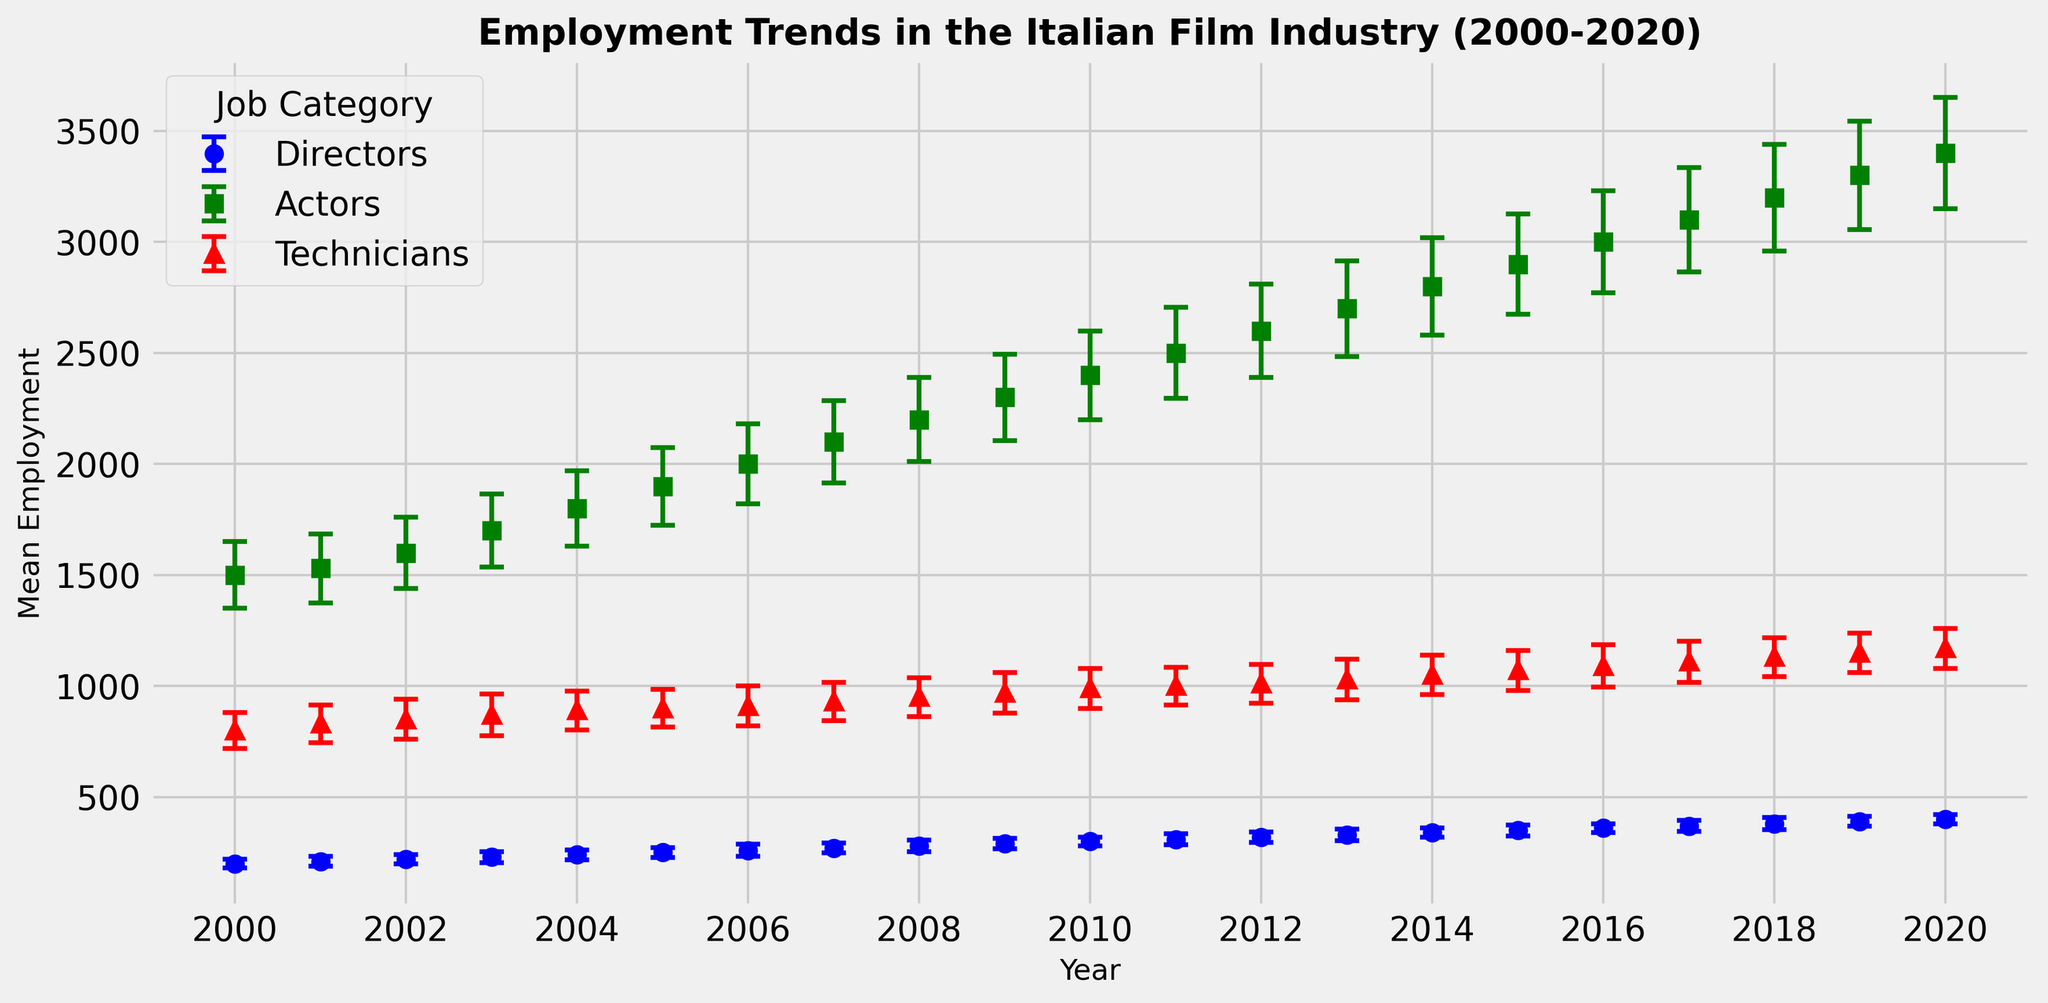What year had the highest mean employment for actors, and what was the mean employment? Look at the green markers representing actors and identify which year has the highest position on the y-axis. According to the plot, that year is 2020 with a mean employment of 3400.
Answer: 2020, 3400 Between which years did the mean employment for technicians increase the most? Examine the red markers for technicians and compare the vertical distances between points year by year. The largest increase appears between 2013 and 2014, where the mean employment increased from 1030 to 1050.
Answer: 2013 to 2014 What is the average mean employment of directors over the period 2000-2020? Sum up the mean employment values for directors from 2000 to 2020 and divide by the number of years (21). Sum: (200 + 210 + 220 + 230 + 240 + 250 + 260 + 270 + 280 + 290 + 300 + 310 + 320 + 330 + 340 + 350 + 360 + 370 + 380 + 390 + 400) = 6300. Thus, 6300 / 21 ≈ 300.
Answer: 300 Which job category shows the most variation in mean employment based on the error bars? Compare the lengths of the error bars for the three job categories. Actors, represented by green markers, have the longest error bars, indicating the greatest variation.
Answer: Actors How did the mean employment trend for directors change from 2000 to 2020? Follow the blue markers corresponding to directors from 2000 to 2020. The markers show a continuous upward trend, indicating a steady increase in mean employment.
Answer: Increased In which year did the mean employment for actors exceed 3000 for the first time? Locate the green markers for actors and find the point where the y-axis value exceeds 3000. This happens in 2015.
Answer: 2015 What is the difference in mean employment between actors and technicians in 2020? Observe the mean employment values for 2020: Actors have 3400 and Technicians have 1170. The difference is 3400 - 1170 = 2230.
Answer: 2230 How does the growth rate of mean employment for technicians from 2000 to 2020 compare with that of directors over the same period? Calculate the initial and final employment for both categories (directors: 200 to 400, technicians: 800 to 1170). For directors, growth is ((400 - 200) / 200) * 100% = 100%. For technicians, growth is ((1170 - 800) / 800) * 100% ≈ 46.25%. Therefore, the growth rate for directors is much higher.
Answer: Directors' growth rate is higher What is the mean employment for technicians in 2006 and what is its standard deviation? Locate the red marker for technicians in 2006. The mean employment is 910, and the standard deviation, given by the error bar’s length, is 90.
Answer: Mean: 910, Standard Deviation: 90 